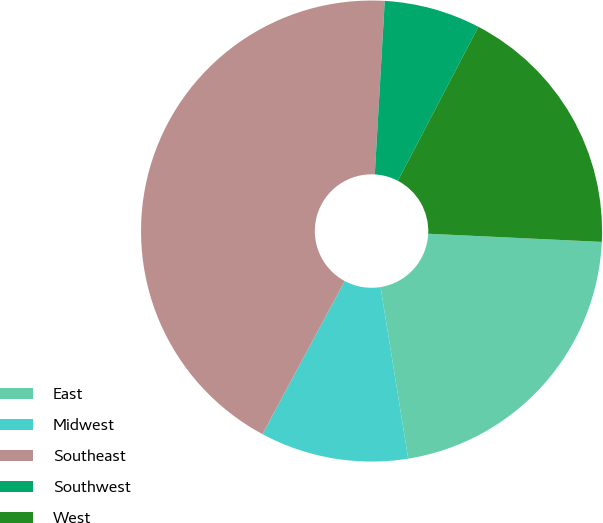<chart> <loc_0><loc_0><loc_500><loc_500><pie_chart><fcel>East<fcel>Midwest<fcel>Southeast<fcel>Southwest<fcel>West<nl><fcel>21.71%<fcel>10.39%<fcel>43.07%<fcel>6.76%<fcel>18.08%<nl></chart> 